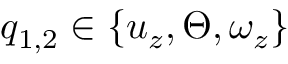Convert formula to latex. <formula><loc_0><loc_0><loc_500><loc_500>q _ { 1 , 2 } \in \{ u _ { z } , \Theta , \omega _ { z } \}</formula> 